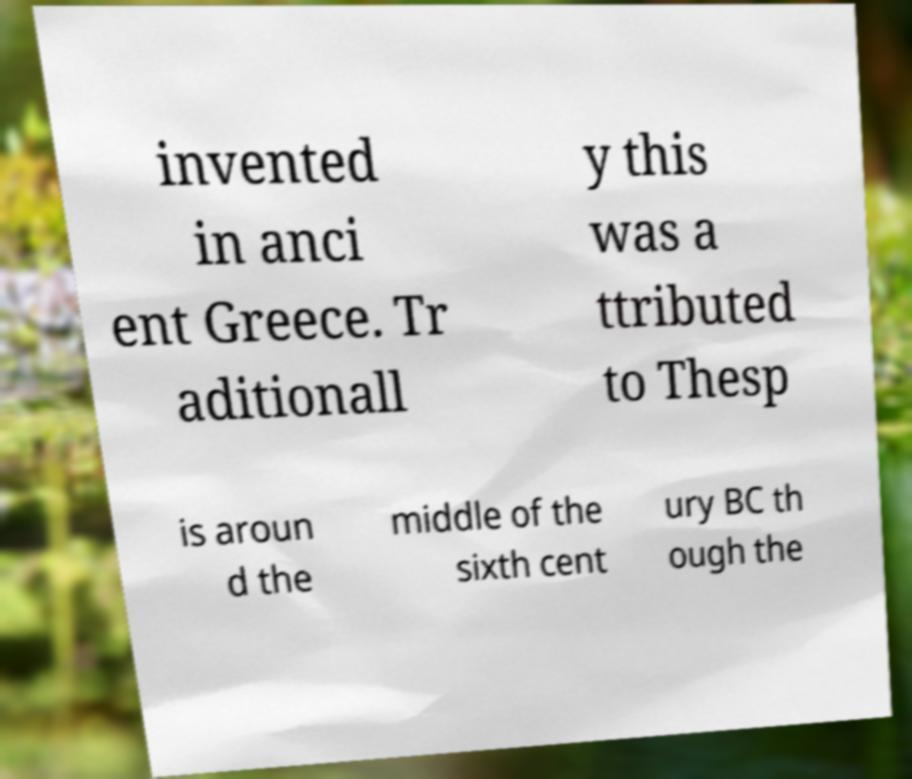There's text embedded in this image that I need extracted. Can you transcribe it verbatim? invented in anci ent Greece. Tr aditionall y this was a ttributed to Thesp is aroun d the middle of the sixth cent ury BC th ough the 